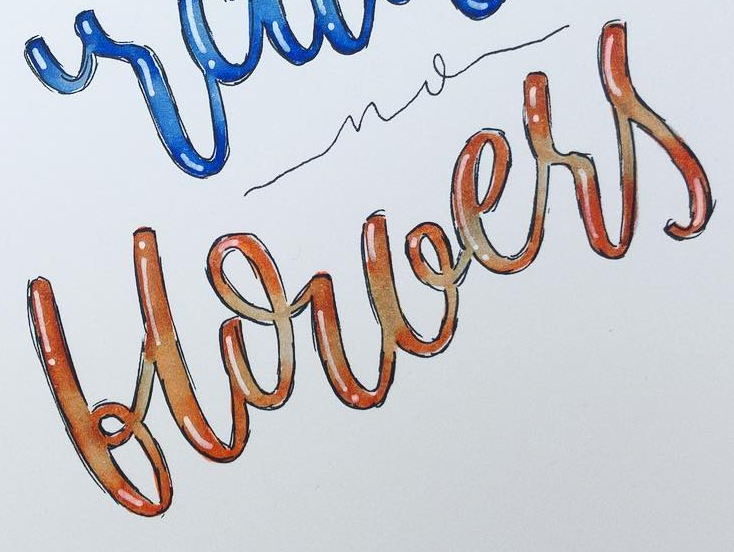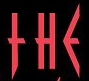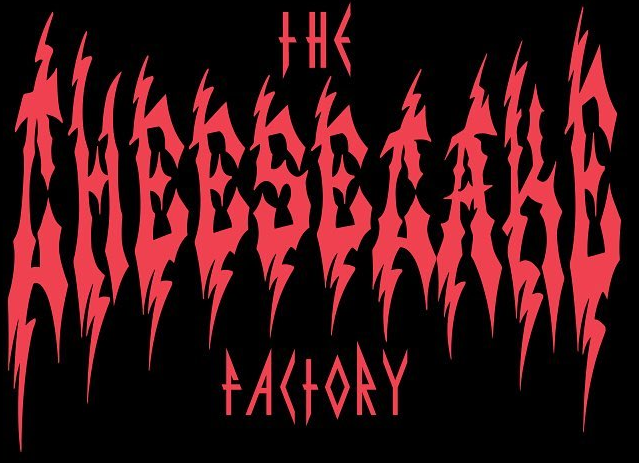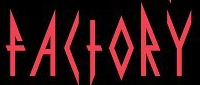Read the text content from these images in order, separated by a semicolon. blouers; THE; CHEESECAKE; FACTORY 